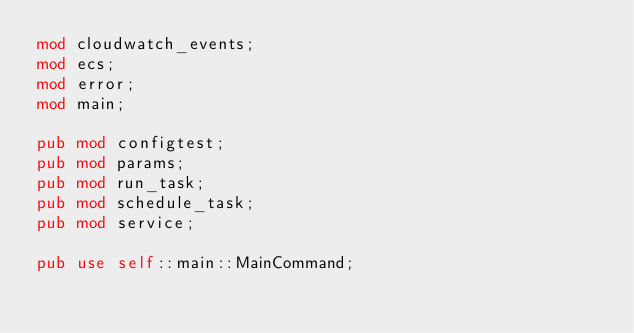Convert code to text. <code><loc_0><loc_0><loc_500><loc_500><_Rust_>mod cloudwatch_events;
mod ecs;
mod error;
mod main;

pub mod configtest;
pub mod params;
pub mod run_task;
pub mod schedule_task;
pub mod service;

pub use self::main::MainCommand;
</code> 